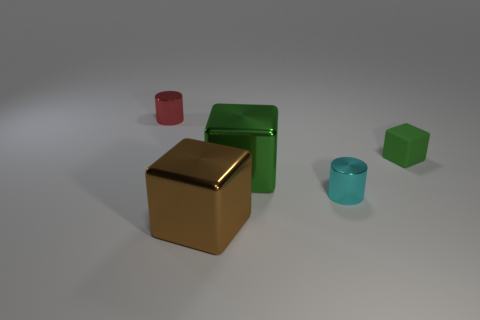What size is the rubber cube?
Give a very brief answer. Small. Is the number of tiny cyan shiny cylinders behind the green metal thing greater than the number of cyan shiny objects?
Make the answer very short. No. Is there anything else that has the same material as the cyan cylinder?
Keep it short and to the point. Yes. Do the tiny metallic cylinder that is to the right of the brown block and the tiny shiny cylinder that is to the left of the brown metallic cube have the same color?
Make the answer very short. No. There is a tiny object that is in front of the large object that is behind the tiny cylinder that is right of the small red thing; what is its material?
Give a very brief answer. Metal. Is the number of brown rubber blocks greater than the number of big brown shiny cubes?
Provide a short and direct response. No. Is there any other thing of the same color as the matte thing?
Ensure brevity in your answer.  Yes. What is the size of the brown block that is the same material as the red cylinder?
Your response must be concise. Large. What is the material of the cyan thing?
Give a very brief answer. Metal. How many red objects are the same size as the brown shiny object?
Make the answer very short. 0. 